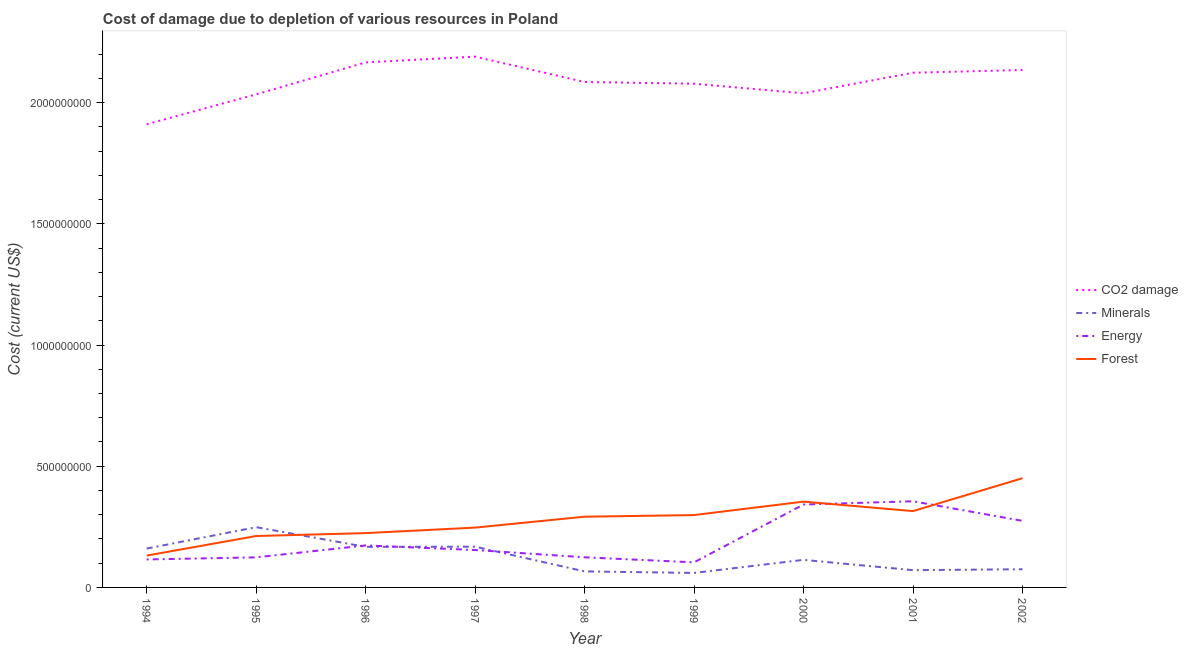What is the cost of damage due to depletion of minerals in 2001?
Provide a short and direct response. 7.12e+07. Across all years, what is the maximum cost of damage due to depletion of forests?
Ensure brevity in your answer.  4.50e+08. Across all years, what is the minimum cost of damage due to depletion of energy?
Make the answer very short. 1.03e+08. In which year was the cost of damage due to depletion of forests minimum?
Keep it short and to the point. 1994. What is the total cost of damage due to depletion of coal in the graph?
Offer a terse response. 1.88e+1. What is the difference between the cost of damage due to depletion of coal in 1998 and that in 2000?
Provide a succinct answer. 4.68e+07. What is the difference between the cost of damage due to depletion of minerals in 1997 and the cost of damage due to depletion of forests in 1995?
Offer a terse response. -4.40e+07. What is the average cost of damage due to depletion of energy per year?
Make the answer very short. 1.96e+08. In the year 1997, what is the difference between the cost of damage due to depletion of minerals and cost of damage due to depletion of energy?
Give a very brief answer. 1.37e+07. What is the ratio of the cost of damage due to depletion of energy in 1997 to that in 2000?
Your answer should be compact. 0.45. Is the cost of damage due to depletion of energy in 1997 less than that in 2001?
Your response must be concise. Yes. Is the difference between the cost of damage due to depletion of forests in 1995 and 1996 greater than the difference between the cost of damage due to depletion of coal in 1995 and 1996?
Offer a terse response. Yes. What is the difference between the highest and the second highest cost of damage due to depletion of energy?
Offer a terse response. 1.34e+07. What is the difference between the highest and the lowest cost of damage due to depletion of coal?
Offer a very short reply. 2.79e+08. In how many years, is the cost of damage due to depletion of minerals greater than the average cost of damage due to depletion of minerals taken over all years?
Your response must be concise. 4. Is it the case that in every year, the sum of the cost of damage due to depletion of minerals and cost of damage due to depletion of forests is greater than the sum of cost of damage due to depletion of energy and cost of damage due to depletion of coal?
Offer a very short reply. No. Is it the case that in every year, the sum of the cost of damage due to depletion of coal and cost of damage due to depletion of minerals is greater than the cost of damage due to depletion of energy?
Offer a terse response. Yes. Does the cost of damage due to depletion of forests monotonically increase over the years?
Offer a very short reply. No. Is the cost of damage due to depletion of forests strictly greater than the cost of damage due to depletion of minerals over the years?
Provide a succinct answer. No. Is the cost of damage due to depletion of coal strictly less than the cost of damage due to depletion of energy over the years?
Offer a very short reply. No. How many years are there in the graph?
Ensure brevity in your answer.  9. Are the values on the major ticks of Y-axis written in scientific E-notation?
Offer a terse response. No. Does the graph contain any zero values?
Provide a short and direct response. No. Does the graph contain grids?
Make the answer very short. No. Where does the legend appear in the graph?
Give a very brief answer. Center right. How many legend labels are there?
Your answer should be compact. 4. What is the title of the graph?
Make the answer very short. Cost of damage due to depletion of various resources in Poland . Does "Compensation of employees" appear as one of the legend labels in the graph?
Ensure brevity in your answer.  No. What is the label or title of the X-axis?
Make the answer very short. Year. What is the label or title of the Y-axis?
Your answer should be compact. Cost (current US$). What is the Cost (current US$) of CO2 damage in 1994?
Make the answer very short. 1.91e+09. What is the Cost (current US$) in Minerals in 1994?
Provide a short and direct response. 1.60e+08. What is the Cost (current US$) of Energy in 1994?
Keep it short and to the point. 1.15e+08. What is the Cost (current US$) in Forest in 1994?
Your answer should be very brief. 1.31e+08. What is the Cost (current US$) in CO2 damage in 1995?
Keep it short and to the point. 2.03e+09. What is the Cost (current US$) in Minerals in 1995?
Offer a terse response. 2.49e+08. What is the Cost (current US$) in Energy in 1995?
Make the answer very short. 1.24e+08. What is the Cost (current US$) of Forest in 1995?
Ensure brevity in your answer.  2.12e+08. What is the Cost (current US$) in CO2 damage in 1996?
Offer a very short reply. 2.17e+09. What is the Cost (current US$) of Minerals in 1996?
Offer a terse response. 1.67e+08. What is the Cost (current US$) of Energy in 1996?
Make the answer very short. 1.73e+08. What is the Cost (current US$) in Forest in 1996?
Provide a succinct answer. 2.24e+08. What is the Cost (current US$) of CO2 damage in 1997?
Make the answer very short. 2.19e+09. What is the Cost (current US$) of Minerals in 1997?
Make the answer very short. 1.68e+08. What is the Cost (current US$) of Energy in 1997?
Provide a succinct answer. 1.54e+08. What is the Cost (current US$) in Forest in 1997?
Your answer should be very brief. 2.47e+08. What is the Cost (current US$) of CO2 damage in 1998?
Provide a short and direct response. 2.09e+09. What is the Cost (current US$) of Minerals in 1998?
Your response must be concise. 6.62e+07. What is the Cost (current US$) in Energy in 1998?
Your response must be concise. 1.24e+08. What is the Cost (current US$) in Forest in 1998?
Your response must be concise. 2.92e+08. What is the Cost (current US$) of CO2 damage in 1999?
Provide a succinct answer. 2.08e+09. What is the Cost (current US$) of Minerals in 1999?
Your answer should be very brief. 5.97e+07. What is the Cost (current US$) of Energy in 1999?
Your answer should be very brief. 1.03e+08. What is the Cost (current US$) of Forest in 1999?
Make the answer very short. 2.98e+08. What is the Cost (current US$) in CO2 damage in 2000?
Ensure brevity in your answer.  2.04e+09. What is the Cost (current US$) of Minerals in 2000?
Ensure brevity in your answer.  1.14e+08. What is the Cost (current US$) of Energy in 2000?
Offer a very short reply. 3.42e+08. What is the Cost (current US$) in Forest in 2000?
Make the answer very short. 3.54e+08. What is the Cost (current US$) in CO2 damage in 2001?
Ensure brevity in your answer.  2.12e+09. What is the Cost (current US$) of Minerals in 2001?
Provide a succinct answer. 7.12e+07. What is the Cost (current US$) in Energy in 2001?
Your answer should be very brief. 3.55e+08. What is the Cost (current US$) in Forest in 2001?
Offer a very short reply. 3.15e+08. What is the Cost (current US$) in CO2 damage in 2002?
Keep it short and to the point. 2.13e+09. What is the Cost (current US$) in Minerals in 2002?
Your response must be concise. 7.50e+07. What is the Cost (current US$) of Energy in 2002?
Provide a short and direct response. 2.75e+08. What is the Cost (current US$) of Forest in 2002?
Your answer should be compact. 4.50e+08. Across all years, what is the maximum Cost (current US$) of CO2 damage?
Your response must be concise. 2.19e+09. Across all years, what is the maximum Cost (current US$) of Minerals?
Offer a terse response. 2.49e+08. Across all years, what is the maximum Cost (current US$) of Energy?
Offer a terse response. 3.55e+08. Across all years, what is the maximum Cost (current US$) of Forest?
Provide a short and direct response. 4.50e+08. Across all years, what is the minimum Cost (current US$) in CO2 damage?
Make the answer very short. 1.91e+09. Across all years, what is the minimum Cost (current US$) of Minerals?
Offer a terse response. 5.97e+07. Across all years, what is the minimum Cost (current US$) in Energy?
Your answer should be compact. 1.03e+08. Across all years, what is the minimum Cost (current US$) in Forest?
Give a very brief answer. 1.31e+08. What is the total Cost (current US$) in CO2 damage in the graph?
Keep it short and to the point. 1.88e+1. What is the total Cost (current US$) in Minerals in the graph?
Offer a very short reply. 1.13e+09. What is the total Cost (current US$) in Energy in the graph?
Your answer should be very brief. 1.77e+09. What is the total Cost (current US$) in Forest in the graph?
Make the answer very short. 2.52e+09. What is the difference between the Cost (current US$) in CO2 damage in 1994 and that in 1995?
Give a very brief answer. -1.23e+08. What is the difference between the Cost (current US$) in Minerals in 1994 and that in 1995?
Keep it short and to the point. -8.83e+07. What is the difference between the Cost (current US$) of Energy in 1994 and that in 1995?
Provide a short and direct response. -8.64e+06. What is the difference between the Cost (current US$) in Forest in 1994 and that in 1995?
Offer a terse response. -8.07e+07. What is the difference between the Cost (current US$) in CO2 damage in 1994 and that in 1996?
Your response must be concise. -2.55e+08. What is the difference between the Cost (current US$) in Minerals in 1994 and that in 1996?
Keep it short and to the point. -7.06e+06. What is the difference between the Cost (current US$) of Energy in 1994 and that in 1996?
Make the answer very short. -5.78e+07. What is the difference between the Cost (current US$) in Forest in 1994 and that in 1996?
Ensure brevity in your answer.  -9.27e+07. What is the difference between the Cost (current US$) in CO2 damage in 1994 and that in 1997?
Your answer should be compact. -2.79e+08. What is the difference between the Cost (current US$) in Minerals in 1994 and that in 1997?
Your answer should be very brief. -7.76e+06. What is the difference between the Cost (current US$) in Energy in 1994 and that in 1997?
Your answer should be compact. -3.90e+07. What is the difference between the Cost (current US$) of Forest in 1994 and that in 1997?
Ensure brevity in your answer.  -1.15e+08. What is the difference between the Cost (current US$) of CO2 damage in 1994 and that in 1998?
Ensure brevity in your answer.  -1.74e+08. What is the difference between the Cost (current US$) of Minerals in 1994 and that in 1998?
Keep it short and to the point. 9.41e+07. What is the difference between the Cost (current US$) of Energy in 1994 and that in 1998?
Your answer should be compact. -8.82e+06. What is the difference between the Cost (current US$) of Forest in 1994 and that in 1998?
Your response must be concise. -1.60e+08. What is the difference between the Cost (current US$) of CO2 damage in 1994 and that in 1999?
Give a very brief answer. -1.67e+08. What is the difference between the Cost (current US$) of Minerals in 1994 and that in 1999?
Ensure brevity in your answer.  1.01e+08. What is the difference between the Cost (current US$) of Energy in 1994 and that in 1999?
Your answer should be very brief. 1.19e+07. What is the difference between the Cost (current US$) in Forest in 1994 and that in 1999?
Provide a succinct answer. -1.67e+08. What is the difference between the Cost (current US$) in CO2 damage in 1994 and that in 2000?
Provide a short and direct response. -1.28e+08. What is the difference between the Cost (current US$) in Minerals in 1994 and that in 2000?
Make the answer very short. 4.66e+07. What is the difference between the Cost (current US$) in Energy in 1994 and that in 2000?
Ensure brevity in your answer.  -2.27e+08. What is the difference between the Cost (current US$) of Forest in 1994 and that in 2000?
Offer a very short reply. -2.23e+08. What is the difference between the Cost (current US$) in CO2 damage in 1994 and that in 2001?
Keep it short and to the point. -2.13e+08. What is the difference between the Cost (current US$) of Minerals in 1994 and that in 2001?
Offer a very short reply. 8.91e+07. What is the difference between the Cost (current US$) of Energy in 1994 and that in 2001?
Offer a very short reply. -2.40e+08. What is the difference between the Cost (current US$) in Forest in 1994 and that in 2001?
Your answer should be compact. -1.84e+08. What is the difference between the Cost (current US$) of CO2 damage in 1994 and that in 2002?
Your answer should be compact. -2.24e+08. What is the difference between the Cost (current US$) of Minerals in 1994 and that in 2002?
Provide a succinct answer. 8.53e+07. What is the difference between the Cost (current US$) of Energy in 1994 and that in 2002?
Your answer should be compact. -1.59e+08. What is the difference between the Cost (current US$) of Forest in 1994 and that in 2002?
Offer a terse response. -3.19e+08. What is the difference between the Cost (current US$) in CO2 damage in 1995 and that in 1996?
Your answer should be compact. -1.32e+08. What is the difference between the Cost (current US$) of Minerals in 1995 and that in 1996?
Provide a short and direct response. 8.12e+07. What is the difference between the Cost (current US$) of Energy in 1995 and that in 1996?
Give a very brief answer. -4.92e+07. What is the difference between the Cost (current US$) of Forest in 1995 and that in 1996?
Provide a succinct answer. -1.20e+07. What is the difference between the Cost (current US$) in CO2 damage in 1995 and that in 1997?
Give a very brief answer. -1.56e+08. What is the difference between the Cost (current US$) in Minerals in 1995 and that in 1997?
Provide a short and direct response. 8.05e+07. What is the difference between the Cost (current US$) of Energy in 1995 and that in 1997?
Provide a succinct answer. -3.04e+07. What is the difference between the Cost (current US$) of Forest in 1995 and that in 1997?
Provide a short and direct response. -3.47e+07. What is the difference between the Cost (current US$) in CO2 damage in 1995 and that in 1998?
Offer a terse response. -5.11e+07. What is the difference between the Cost (current US$) in Minerals in 1995 and that in 1998?
Provide a succinct answer. 1.82e+08. What is the difference between the Cost (current US$) in Energy in 1995 and that in 1998?
Ensure brevity in your answer.  -1.83e+05. What is the difference between the Cost (current US$) of Forest in 1995 and that in 1998?
Ensure brevity in your answer.  -7.97e+07. What is the difference between the Cost (current US$) of CO2 damage in 1995 and that in 1999?
Ensure brevity in your answer.  -4.40e+07. What is the difference between the Cost (current US$) in Minerals in 1995 and that in 1999?
Give a very brief answer. 1.89e+08. What is the difference between the Cost (current US$) in Energy in 1995 and that in 1999?
Your answer should be very brief. 2.06e+07. What is the difference between the Cost (current US$) of Forest in 1995 and that in 1999?
Your answer should be compact. -8.64e+07. What is the difference between the Cost (current US$) in CO2 damage in 1995 and that in 2000?
Offer a very short reply. -4.34e+06. What is the difference between the Cost (current US$) in Minerals in 1995 and that in 2000?
Offer a very short reply. 1.35e+08. What is the difference between the Cost (current US$) in Energy in 1995 and that in 2000?
Offer a terse response. -2.18e+08. What is the difference between the Cost (current US$) in Forest in 1995 and that in 2000?
Make the answer very short. -1.42e+08. What is the difference between the Cost (current US$) of CO2 damage in 1995 and that in 2001?
Your response must be concise. -8.93e+07. What is the difference between the Cost (current US$) in Minerals in 1995 and that in 2001?
Make the answer very short. 1.77e+08. What is the difference between the Cost (current US$) of Energy in 1995 and that in 2001?
Your answer should be very brief. -2.31e+08. What is the difference between the Cost (current US$) in Forest in 1995 and that in 2001?
Your answer should be very brief. -1.03e+08. What is the difference between the Cost (current US$) in CO2 damage in 1995 and that in 2002?
Keep it short and to the point. -1.01e+08. What is the difference between the Cost (current US$) in Minerals in 1995 and that in 2002?
Give a very brief answer. 1.74e+08. What is the difference between the Cost (current US$) in Energy in 1995 and that in 2002?
Ensure brevity in your answer.  -1.51e+08. What is the difference between the Cost (current US$) in Forest in 1995 and that in 2002?
Provide a short and direct response. -2.38e+08. What is the difference between the Cost (current US$) of CO2 damage in 1996 and that in 1997?
Offer a terse response. -2.39e+07. What is the difference between the Cost (current US$) of Minerals in 1996 and that in 1997?
Keep it short and to the point. -6.99e+05. What is the difference between the Cost (current US$) in Energy in 1996 and that in 1997?
Ensure brevity in your answer.  1.88e+07. What is the difference between the Cost (current US$) of Forest in 1996 and that in 1997?
Make the answer very short. -2.27e+07. What is the difference between the Cost (current US$) of CO2 damage in 1996 and that in 1998?
Offer a very short reply. 8.07e+07. What is the difference between the Cost (current US$) of Minerals in 1996 and that in 1998?
Your answer should be very brief. 1.01e+08. What is the difference between the Cost (current US$) in Energy in 1996 and that in 1998?
Make the answer very short. 4.90e+07. What is the difference between the Cost (current US$) of Forest in 1996 and that in 1998?
Offer a terse response. -6.77e+07. What is the difference between the Cost (current US$) of CO2 damage in 1996 and that in 1999?
Make the answer very short. 8.78e+07. What is the difference between the Cost (current US$) of Minerals in 1996 and that in 1999?
Offer a terse response. 1.08e+08. What is the difference between the Cost (current US$) of Energy in 1996 and that in 1999?
Provide a succinct answer. 6.97e+07. What is the difference between the Cost (current US$) in Forest in 1996 and that in 1999?
Provide a short and direct response. -7.44e+07. What is the difference between the Cost (current US$) in CO2 damage in 1996 and that in 2000?
Give a very brief answer. 1.27e+08. What is the difference between the Cost (current US$) of Minerals in 1996 and that in 2000?
Make the answer very short. 5.36e+07. What is the difference between the Cost (current US$) in Energy in 1996 and that in 2000?
Ensure brevity in your answer.  -1.69e+08. What is the difference between the Cost (current US$) of Forest in 1996 and that in 2000?
Give a very brief answer. -1.30e+08. What is the difference between the Cost (current US$) in CO2 damage in 1996 and that in 2001?
Provide a succinct answer. 4.25e+07. What is the difference between the Cost (current US$) of Minerals in 1996 and that in 2001?
Give a very brief answer. 9.62e+07. What is the difference between the Cost (current US$) in Energy in 1996 and that in 2001?
Ensure brevity in your answer.  -1.82e+08. What is the difference between the Cost (current US$) in Forest in 1996 and that in 2001?
Make the answer very short. -9.08e+07. What is the difference between the Cost (current US$) of CO2 damage in 1996 and that in 2002?
Keep it short and to the point. 3.12e+07. What is the difference between the Cost (current US$) in Minerals in 1996 and that in 2002?
Your response must be concise. 9.24e+07. What is the difference between the Cost (current US$) of Energy in 1996 and that in 2002?
Make the answer very short. -1.01e+08. What is the difference between the Cost (current US$) of Forest in 1996 and that in 2002?
Your answer should be very brief. -2.26e+08. What is the difference between the Cost (current US$) in CO2 damage in 1997 and that in 1998?
Keep it short and to the point. 1.05e+08. What is the difference between the Cost (current US$) of Minerals in 1997 and that in 1998?
Offer a very short reply. 1.02e+08. What is the difference between the Cost (current US$) in Energy in 1997 and that in 1998?
Your response must be concise. 3.02e+07. What is the difference between the Cost (current US$) of Forest in 1997 and that in 1998?
Make the answer very short. -4.50e+07. What is the difference between the Cost (current US$) in CO2 damage in 1997 and that in 1999?
Keep it short and to the point. 1.12e+08. What is the difference between the Cost (current US$) of Minerals in 1997 and that in 1999?
Your response must be concise. 1.08e+08. What is the difference between the Cost (current US$) of Energy in 1997 and that in 1999?
Give a very brief answer. 5.09e+07. What is the difference between the Cost (current US$) of Forest in 1997 and that in 1999?
Provide a succinct answer. -5.17e+07. What is the difference between the Cost (current US$) in CO2 damage in 1997 and that in 2000?
Ensure brevity in your answer.  1.51e+08. What is the difference between the Cost (current US$) in Minerals in 1997 and that in 2000?
Keep it short and to the point. 5.43e+07. What is the difference between the Cost (current US$) of Energy in 1997 and that in 2000?
Provide a short and direct response. -1.88e+08. What is the difference between the Cost (current US$) in Forest in 1997 and that in 2000?
Your answer should be compact. -1.07e+08. What is the difference between the Cost (current US$) in CO2 damage in 1997 and that in 2001?
Your answer should be very brief. 6.63e+07. What is the difference between the Cost (current US$) in Minerals in 1997 and that in 2001?
Provide a succinct answer. 9.69e+07. What is the difference between the Cost (current US$) in Energy in 1997 and that in 2001?
Keep it short and to the point. -2.01e+08. What is the difference between the Cost (current US$) of Forest in 1997 and that in 2001?
Give a very brief answer. -6.81e+07. What is the difference between the Cost (current US$) in CO2 damage in 1997 and that in 2002?
Provide a short and direct response. 5.51e+07. What is the difference between the Cost (current US$) in Minerals in 1997 and that in 2002?
Make the answer very short. 9.31e+07. What is the difference between the Cost (current US$) in Energy in 1997 and that in 2002?
Your answer should be very brief. -1.20e+08. What is the difference between the Cost (current US$) of Forest in 1997 and that in 2002?
Your response must be concise. -2.04e+08. What is the difference between the Cost (current US$) in CO2 damage in 1998 and that in 1999?
Give a very brief answer. 7.10e+06. What is the difference between the Cost (current US$) in Minerals in 1998 and that in 1999?
Your response must be concise. 6.44e+06. What is the difference between the Cost (current US$) of Energy in 1998 and that in 1999?
Offer a very short reply. 2.08e+07. What is the difference between the Cost (current US$) in Forest in 1998 and that in 1999?
Keep it short and to the point. -6.70e+06. What is the difference between the Cost (current US$) of CO2 damage in 1998 and that in 2000?
Ensure brevity in your answer.  4.68e+07. What is the difference between the Cost (current US$) in Minerals in 1998 and that in 2000?
Your response must be concise. -4.76e+07. What is the difference between the Cost (current US$) of Energy in 1998 and that in 2000?
Provide a succinct answer. -2.18e+08. What is the difference between the Cost (current US$) in Forest in 1998 and that in 2000?
Your answer should be very brief. -6.22e+07. What is the difference between the Cost (current US$) in CO2 damage in 1998 and that in 2001?
Your answer should be very brief. -3.82e+07. What is the difference between the Cost (current US$) of Minerals in 1998 and that in 2001?
Give a very brief answer. -5.05e+06. What is the difference between the Cost (current US$) in Energy in 1998 and that in 2001?
Your answer should be compact. -2.31e+08. What is the difference between the Cost (current US$) in Forest in 1998 and that in 2001?
Your answer should be compact. -2.32e+07. What is the difference between the Cost (current US$) in CO2 damage in 1998 and that in 2002?
Offer a terse response. -4.95e+07. What is the difference between the Cost (current US$) in Minerals in 1998 and that in 2002?
Make the answer very short. -8.80e+06. What is the difference between the Cost (current US$) in Energy in 1998 and that in 2002?
Your answer should be compact. -1.50e+08. What is the difference between the Cost (current US$) of Forest in 1998 and that in 2002?
Your answer should be very brief. -1.59e+08. What is the difference between the Cost (current US$) in CO2 damage in 1999 and that in 2000?
Provide a short and direct response. 3.97e+07. What is the difference between the Cost (current US$) of Minerals in 1999 and that in 2000?
Provide a short and direct response. -5.40e+07. What is the difference between the Cost (current US$) of Energy in 1999 and that in 2000?
Provide a succinct answer. -2.39e+08. What is the difference between the Cost (current US$) in Forest in 1999 and that in 2000?
Offer a very short reply. -5.55e+07. What is the difference between the Cost (current US$) of CO2 damage in 1999 and that in 2001?
Provide a succinct answer. -4.53e+07. What is the difference between the Cost (current US$) in Minerals in 1999 and that in 2001?
Ensure brevity in your answer.  -1.15e+07. What is the difference between the Cost (current US$) in Energy in 1999 and that in 2001?
Your answer should be very brief. -2.52e+08. What is the difference between the Cost (current US$) in Forest in 1999 and that in 2001?
Make the answer very short. -1.65e+07. What is the difference between the Cost (current US$) of CO2 damage in 1999 and that in 2002?
Provide a succinct answer. -5.66e+07. What is the difference between the Cost (current US$) in Minerals in 1999 and that in 2002?
Your answer should be very brief. -1.52e+07. What is the difference between the Cost (current US$) of Energy in 1999 and that in 2002?
Give a very brief answer. -1.71e+08. What is the difference between the Cost (current US$) of Forest in 1999 and that in 2002?
Your answer should be very brief. -1.52e+08. What is the difference between the Cost (current US$) of CO2 damage in 2000 and that in 2001?
Give a very brief answer. -8.50e+07. What is the difference between the Cost (current US$) in Minerals in 2000 and that in 2001?
Your answer should be very brief. 4.25e+07. What is the difference between the Cost (current US$) of Energy in 2000 and that in 2001?
Your answer should be compact. -1.34e+07. What is the difference between the Cost (current US$) in Forest in 2000 and that in 2001?
Ensure brevity in your answer.  3.90e+07. What is the difference between the Cost (current US$) of CO2 damage in 2000 and that in 2002?
Provide a short and direct response. -9.62e+07. What is the difference between the Cost (current US$) in Minerals in 2000 and that in 2002?
Your answer should be very brief. 3.88e+07. What is the difference between the Cost (current US$) in Energy in 2000 and that in 2002?
Your response must be concise. 6.73e+07. What is the difference between the Cost (current US$) in Forest in 2000 and that in 2002?
Provide a short and direct response. -9.65e+07. What is the difference between the Cost (current US$) in CO2 damage in 2001 and that in 2002?
Provide a short and direct response. -1.12e+07. What is the difference between the Cost (current US$) in Minerals in 2001 and that in 2002?
Provide a succinct answer. -3.75e+06. What is the difference between the Cost (current US$) in Energy in 2001 and that in 2002?
Your answer should be very brief. 8.07e+07. What is the difference between the Cost (current US$) in Forest in 2001 and that in 2002?
Ensure brevity in your answer.  -1.36e+08. What is the difference between the Cost (current US$) in CO2 damage in 1994 and the Cost (current US$) in Minerals in 1995?
Provide a succinct answer. 1.66e+09. What is the difference between the Cost (current US$) of CO2 damage in 1994 and the Cost (current US$) of Energy in 1995?
Ensure brevity in your answer.  1.79e+09. What is the difference between the Cost (current US$) in CO2 damage in 1994 and the Cost (current US$) in Forest in 1995?
Your answer should be very brief. 1.70e+09. What is the difference between the Cost (current US$) in Minerals in 1994 and the Cost (current US$) in Energy in 1995?
Give a very brief answer. 3.63e+07. What is the difference between the Cost (current US$) of Minerals in 1994 and the Cost (current US$) of Forest in 1995?
Your answer should be compact. -5.18e+07. What is the difference between the Cost (current US$) in Energy in 1994 and the Cost (current US$) in Forest in 1995?
Your answer should be very brief. -9.67e+07. What is the difference between the Cost (current US$) of CO2 damage in 1994 and the Cost (current US$) of Minerals in 1996?
Your answer should be very brief. 1.74e+09. What is the difference between the Cost (current US$) of CO2 damage in 1994 and the Cost (current US$) of Energy in 1996?
Offer a very short reply. 1.74e+09. What is the difference between the Cost (current US$) in CO2 damage in 1994 and the Cost (current US$) in Forest in 1996?
Offer a terse response. 1.69e+09. What is the difference between the Cost (current US$) of Minerals in 1994 and the Cost (current US$) of Energy in 1996?
Offer a terse response. -1.29e+07. What is the difference between the Cost (current US$) in Minerals in 1994 and the Cost (current US$) in Forest in 1996?
Make the answer very short. -6.38e+07. What is the difference between the Cost (current US$) in Energy in 1994 and the Cost (current US$) in Forest in 1996?
Keep it short and to the point. -1.09e+08. What is the difference between the Cost (current US$) in CO2 damage in 1994 and the Cost (current US$) in Minerals in 1997?
Give a very brief answer. 1.74e+09. What is the difference between the Cost (current US$) in CO2 damage in 1994 and the Cost (current US$) in Energy in 1997?
Offer a terse response. 1.76e+09. What is the difference between the Cost (current US$) of CO2 damage in 1994 and the Cost (current US$) of Forest in 1997?
Provide a succinct answer. 1.66e+09. What is the difference between the Cost (current US$) of Minerals in 1994 and the Cost (current US$) of Energy in 1997?
Offer a very short reply. 5.92e+06. What is the difference between the Cost (current US$) in Minerals in 1994 and the Cost (current US$) in Forest in 1997?
Your answer should be compact. -8.65e+07. What is the difference between the Cost (current US$) of Energy in 1994 and the Cost (current US$) of Forest in 1997?
Your response must be concise. -1.31e+08. What is the difference between the Cost (current US$) in CO2 damage in 1994 and the Cost (current US$) in Minerals in 1998?
Offer a very short reply. 1.84e+09. What is the difference between the Cost (current US$) of CO2 damage in 1994 and the Cost (current US$) of Energy in 1998?
Your response must be concise. 1.79e+09. What is the difference between the Cost (current US$) of CO2 damage in 1994 and the Cost (current US$) of Forest in 1998?
Your answer should be very brief. 1.62e+09. What is the difference between the Cost (current US$) in Minerals in 1994 and the Cost (current US$) in Energy in 1998?
Your response must be concise. 3.61e+07. What is the difference between the Cost (current US$) in Minerals in 1994 and the Cost (current US$) in Forest in 1998?
Provide a succinct answer. -1.31e+08. What is the difference between the Cost (current US$) in Energy in 1994 and the Cost (current US$) in Forest in 1998?
Ensure brevity in your answer.  -1.76e+08. What is the difference between the Cost (current US$) in CO2 damage in 1994 and the Cost (current US$) in Minerals in 1999?
Offer a very short reply. 1.85e+09. What is the difference between the Cost (current US$) of CO2 damage in 1994 and the Cost (current US$) of Energy in 1999?
Your answer should be very brief. 1.81e+09. What is the difference between the Cost (current US$) in CO2 damage in 1994 and the Cost (current US$) in Forest in 1999?
Make the answer very short. 1.61e+09. What is the difference between the Cost (current US$) in Minerals in 1994 and the Cost (current US$) in Energy in 1999?
Make the answer very short. 5.68e+07. What is the difference between the Cost (current US$) of Minerals in 1994 and the Cost (current US$) of Forest in 1999?
Ensure brevity in your answer.  -1.38e+08. What is the difference between the Cost (current US$) of Energy in 1994 and the Cost (current US$) of Forest in 1999?
Offer a very short reply. -1.83e+08. What is the difference between the Cost (current US$) of CO2 damage in 1994 and the Cost (current US$) of Minerals in 2000?
Keep it short and to the point. 1.80e+09. What is the difference between the Cost (current US$) of CO2 damage in 1994 and the Cost (current US$) of Energy in 2000?
Offer a very short reply. 1.57e+09. What is the difference between the Cost (current US$) of CO2 damage in 1994 and the Cost (current US$) of Forest in 2000?
Your response must be concise. 1.56e+09. What is the difference between the Cost (current US$) in Minerals in 1994 and the Cost (current US$) in Energy in 2000?
Offer a terse response. -1.82e+08. What is the difference between the Cost (current US$) in Minerals in 1994 and the Cost (current US$) in Forest in 2000?
Your answer should be compact. -1.94e+08. What is the difference between the Cost (current US$) of Energy in 1994 and the Cost (current US$) of Forest in 2000?
Your response must be concise. -2.39e+08. What is the difference between the Cost (current US$) of CO2 damage in 1994 and the Cost (current US$) of Minerals in 2001?
Ensure brevity in your answer.  1.84e+09. What is the difference between the Cost (current US$) of CO2 damage in 1994 and the Cost (current US$) of Energy in 2001?
Keep it short and to the point. 1.56e+09. What is the difference between the Cost (current US$) of CO2 damage in 1994 and the Cost (current US$) of Forest in 2001?
Your answer should be very brief. 1.60e+09. What is the difference between the Cost (current US$) of Minerals in 1994 and the Cost (current US$) of Energy in 2001?
Offer a terse response. -1.95e+08. What is the difference between the Cost (current US$) of Minerals in 1994 and the Cost (current US$) of Forest in 2001?
Offer a terse response. -1.55e+08. What is the difference between the Cost (current US$) in Energy in 1994 and the Cost (current US$) in Forest in 2001?
Keep it short and to the point. -2.00e+08. What is the difference between the Cost (current US$) of CO2 damage in 1994 and the Cost (current US$) of Minerals in 2002?
Your response must be concise. 1.84e+09. What is the difference between the Cost (current US$) of CO2 damage in 1994 and the Cost (current US$) of Energy in 2002?
Make the answer very short. 1.64e+09. What is the difference between the Cost (current US$) in CO2 damage in 1994 and the Cost (current US$) in Forest in 2002?
Offer a very short reply. 1.46e+09. What is the difference between the Cost (current US$) of Minerals in 1994 and the Cost (current US$) of Energy in 2002?
Make the answer very short. -1.14e+08. What is the difference between the Cost (current US$) in Minerals in 1994 and the Cost (current US$) in Forest in 2002?
Your answer should be very brief. -2.90e+08. What is the difference between the Cost (current US$) in Energy in 1994 and the Cost (current US$) in Forest in 2002?
Offer a very short reply. -3.35e+08. What is the difference between the Cost (current US$) in CO2 damage in 1995 and the Cost (current US$) in Minerals in 1996?
Make the answer very short. 1.87e+09. What is the difference between the Cost (current US$) of CO2 damage in 1995 and the Cost (current US$) of Energy in 1996?
Give a very brief answer. 1.86e+09. What is the difference between the Cost (current US$) of CO2 damage in 1995 and the Cost (current US$) of Forest in 1996?
Make the answer very short. 1.81e+09. What is the difference between the Cost (current US$) of Minerals in 1995 and the Cost (current US$) of Energy in 1996?
Keep it short and to the point. 7.54e+07. What is the difference between the Cost (current US$) of Minerals in 1995 and the Cost (current US$) of Forest in 1996?
Provide a short and direct response. 2.45e+07. What is the difference between the Cost (current US$) of Energy in 1995 and the Cost (current US$) of Forest in 1996?
Offer a very short reply. -1.00e+08. What is the difference between the Cost (current US$) of CO2 damage in 1995 and the Cost (current US$) of Minerals in 1997?
Offer a very short reply. 1.87e+09. What is the difference between the Cost (current US$) in CO2 damage in 1995 and the Cost (current US$) in Energy in 1997?
Offer a very short reply. 1.88e+09. What is the difference between the Cost (current US$) in CO2 damage in 1995 and the Cost (current US$) in Forest in 1997?
Provide a short and direct response. 1.79e+09. What is the difference between the Cost (current US$) of Minerals in 1995 and the Cost (current US$) of Energy in 1997?
Provide a short and direct response. 9.42e+07. What is the difference between the Cost (current US$) in Minerals in 1995 and the Cost (current US$) in Forest in 1997?
Give a very brief answer. 1.80e+06. What is the difference between the Cost (current US$) of Energy in 1995 and the Cost (current US$) of Forest in 1997?
Offer a terse response. -1.23e+08. What is the difference between the Cost (current US$) of CO2 damage in 1995 and the Cost (current US$) of Minerals in 1998?
Keep it short and to the point. 1.97e+09. What is the difference between the Cost (current US$) of CO2 damage in 1995 and the Cost (current US$) of Energy in 1998?
Ensure brevity in your answer.  1.91e+09. What is the difference between the Cost (current US$) of CO2 damage in 1995 and the Cost (current US$) of Forest in 1998?
Your answer should be very brief. 1.74e+09. What is the difference between the Cost (current US$) of Minerals in 1995 and the Cost (current US$) of Energy in 1998?
Give a very brief answer. 1.24e+08. What is the difference between the Cost (current US$) of Minerals in 1995 and the Cost (current US$) of Forest in 1998?
Your response must be concise. -4.32e+07. What is the difference between the Cost (current US$) in Energy in 1995 and the Cost (current US$) in Forest in 1998?
Keep it short and to the point. -1.68e+08. What is the difference between the Cost (current US$) in CO2 damage in 1995 and the Cost (current US$) in Minerals in 1999?
Offer a terse response. 1.97e+09. What is the difference between the Cost (current US$) of CO2 damage in 1995 and the Cost (current US$) of Energy in 1999?
Ensure brevity in your answer.  1.93e+09. What is the difference between the Cost (current US$) in CO2 damage in 1995 and the Cost (current US$) in Forest in 1999?
Make the answer very short. 1.74e+09. What is the difference between the Cost (current US$) of Minerals in 1995 and the Cost (current US$) of Energy in 1999?
Provide a short and direct response. 1.45e+08. What is the difference between the Cost (current US$) of Minerals in 1995 and the Cost (current US$) of Forest in 1999?
Make the answer very short. -4.99e+07. What is the difference between the Cost (current US$) of Energy in 1995 and the Cost (current US$) of Forest in 1999?
Your response must be concise. -1.74e+08. What is the difference between the Cost (current US$) in CO2 damage in 1995 and the Cost (current US$) in Minerals in 2000?
Your answer should be compact. 1.92e+09. What is the difference between the Cost (current US$) of CO2 damage in 1995 and the Cost (current US$) of Energy in 2000?
Provide a short and direct response. 1.69e+09. What is the difference between the Cost (current US$) of CO2 damage in 1995 and the Cost (current US$) of Forest in 2000?
Offer a terse response. 1.68e+09. What is the difference between the Cost (current US$) of Minerals in 1995 and the Cost (current US$) of Energy in 2000?
Your answer should be very brief. -9.34e+07. What is the difference between the Cost (current US$) of Minerals in 1995 and the Cost (current US$) of Forest in 2000?
Provide a succinct answer. -1.05e+08. What is the difference between the Cost (current US$) in Energy in 1995 and the Cost (current US$) in Forest in 2000?
Make the answer very short. -2.30e+08. What is the difference between the Cost (current US$) in CO2 damage in 1995 and the Cost (current US$) in Minerals in 2001?
Provide a short and direct response. 1.96e+09. What is the difference between the Cost (current US$) of CO2 damage in 1995 and the Cost (current US$) of Energy in 2001?
Provide a succinct answer. 1.68e+09. What is the difference between the Cost (current US$) of CO2 damage in 1995 and the Cost (current US$) of Forest in 2001?
Keep it short and to the point. 1.72e+09. What is the difference between the Cost (current US$) of Minerals in 1995 and the Cost (current US$) of Energy in 2001?
Provide a short and direct response. -1.07e+08. What is the difference between the Cost (current US$) in Minerals in 1995 and the Cost (current US$) in Forest in 2001?
Provide a succinct answer. -6.63e+07. What is the difference between the Cost (current US$) of Energy in 1995 and the Cost (current US$) of Forest in 2001?
Offer a very short reply. -1.91e+08. What is the difference between the Cost (current US$) of CO2 damage in 1995 and the Cost (current US$) of Minerals in 2002?
Your response must be concise. 1.96e+09. What is the difference between the Cost (current US$) in CO2 damage in 1995 and the Cost (current US$) in Energy in 2002?
Provide a succinct answer. 1.76e+09. What is the difference between the Cost (current US$) of CO2 damage in 1995 and the Cost (current US$) of Forest in 2002?
Your answer should be very brief. 1.58e+09. What is the difference between the Cost (current US$) of Minerals in 1995 and the Cost (current US$) of Energy in 2002?
Ensure brevity in your answer.  -2.61e+07. What is the difference between the Cost (current US$) in Minerals in 1995 and the Cost (current US$) in Forest in 2002?
Offer a terse response. -2.02e+08. What is the difference between the Cost (current US$) in Energy in 1995 and the Cost (current US$) in Forest in 2002?
Offer a very short reply. -3.26e+08. What is the difference between the Cost (current US$) of CO2 damage in 1996 and the Cost (current US$) of Minerals in 1997?
Provide a short and direct response. 2.00e+09. What is the difference between the Cost (current US$) of CO2 damage in 1996 and the Cost (current US$) of Energy in 1997?
Offer a terse response. 2.01e+09. What is the difference between the Cost (current US$) in CO2 damage in 1996 and the Cost (current US$) in Forest in 1997?
Give a very brief answer. 1.92e+09. What is the difference between the Cost (current US$) in Minerals in 1996 and the Cost (current US$) in Energy in 1997?
Provide a succinct answer. 1.30e+07. What is the difference between the Cost (current US$) in Minerals in 1996 and the Cost (current US$) in Forest in 1997?
Keep it short and to the point. -7.94e+07. What is the difference between the Cost (current US$) of Energy in 1996 and the Cost (current US$) of Forest in 1997?
Offer a terse response. -7.36e+07. What is the difference between the Cost (current US$) of CO2 damage in 1996 and the Cost (current US$) of Minerals in 1998?
Keep it short and to the point. 2.10e+09. What is the difference between the Cost (current US$) in CO2 damage in 1996 and the Cost (current US$) in Energy in 1998?
Keep it short and to the point. 2.04e+09. What is the difference between the Cost (current US$) in CO2 damage in 1996 and the Cost (current US$) in Forest in 1998?
Ensure brevity in your answer.  1.87e+09. What is the difference between the Cost (current US$) in Minerals in 1996 and the Cost (current US$) in Energy in 1998?
Your response must be concise. 4.32e+07. What is the difference between the Cost (current US$) of Minerals in 1996 and the Cost (current US$) of Forest in 1998?
Provide a short and direct response. -1.24e+08. What is the difference between the Cost (current US$) of Energy in 1996 and the Cost (current US$) of Forest in 1998?
Give a very brief answer. -1.19e+08. What is the difference between the Cost (current US$) of CO2 damage in 1996 and the Cost (current US$) of Minerals in 1999?
Provide a short and direct response. 2.11e+09. What is the difference between the Cost (current US$) in CO2 damage in 1996 and the Cost (current US$) in Energy in 1999?
Offer a very short reply. 2.06e+09. What is the difference between the Cost (current US$) of CO2 damage in 1996 and the Cost (current US$) of Forest in 1999?
Your answer should be compact. 1.87e+09. What is the difference between the Cost (current US$) of Minerals in 1996 and the Cost (current US$) of Energy in 1999?
Make the answer very short. 6.39e+07. What is the difference between the Cost (current US$) of Minerals in 1996 and the Cost (current US$) of Forest in 1999?
Ensure brevity in your answer.  -1.31e+08. What is the difference between the Cost (current US$) in Energy in 1996 and the Cost (current US$) in Forest in 1999?
Your answer should be compact. -1.25e+08. What is the difference between the Cost (current US$) of CO2 damage in 1996 and the Cost (current US$) of Minerals in 2000?
Your answer should be compact. 2.05e+09. What is the difference between the Cost (current US$) in CO2 damage in 1996 and the Cost (current US$) in Energy in 2000?
Your answer should be compact. 1.82e+09. What is the difference between the Cost (current US$) in CO2 damage in 1996 and the Cost (current US$) in Forest in 2000?
Ensure brevity in your answer.  1.81e+09. What is the difference between the Cost (current US$) in Minerals in 1996 and the Cost (current US$) in Energy in 2000?
Your answer should be very brief. -1.75e+08. What is the difference between the Cost (current US$) of Minerals in 1996 and the Cost (current US$) of Forest in 2000?
Keep it short and to the point. -1.87e+08. What is the difference between the Cost (current US$) in Energy in 1996 and the Cost (current US$) in Forest in 2000?
Keep it short and to the point. -1.81e+08. What is the difference between the Cost (current US$) in CO2 damage in 1996 and the Cost (current US$) in Minerals in 2001?
Offer a terse response. 2.09e+09. What is the difference between the Cost (current US$) in CO2 damage in 1996 and the Cost (current US$) in Energy in 2001?
Make the answer very short. 1.81e+09. What is the difference between the Cost (current US$) of CO2 damage in 1996 and the Cost (current US$) of Forest in 2001?
Offer a very short reply. 1.85e+09. What is the difference between the Cost (current US$) of Minerals in 1996 and the Cost (current US$) of Energy in 2001?
Provide a succinct answer. -1.88e+08. What is the difference between the Cost (current US$) in Minerals in 1996 and the Cost (current US$) in Forest in 2001?
Keep it short and to the point. -1.48e+08. What is the difference between the Cost (current US$) in Energy in 1996 and the Cost (current US$) in Forest in 2001?
Ensure brevity in your answer.  -1.42e+08. What is the difference between the Cost (current US$) in CO2 damage in 1996 and the Cost (current US$) in Minerals in 2002?
Make the answer very short. 2.09e+09. What is the difference between the Cost (current US$) in CO2 damage in 1996 and the Cost (current US$) in Energy in 2002?
Provide a succinct answer. 1.89e+09. What is the difference between the Cost (current US$) of CO2 damage in 1996 and the Cost (current US$) of Forest in 2002?
Offer a terse response. 1.72e+09. What is the difference between the Cost (current US$) in Minerals in 1996 and the Cost (current US$) in Energy in 2002?
Offer a terse response. -1.07e+08. What is the difference between the Cost (current US$) of Minerals in 1996 and the Cost (current US$) of Forest in 2002?
Provide a succinct answer. -2.83e+08. What is the difference between the Cost (current US$) in Energy in 1996 and the Cost (current US$) in Forest in 2002?
Your answer should be very brief. -2.77e+08. What is the difference between the Cost (current US$) in CO2 damage in 1997 and the Cost (current US$) in Minerals in 1998?
Offer a terse response. 2.12e+09. What is the difference between the Cost (current US$) in CO2 damage in 1997 and the Cost (current US$) in Energy in 1998?
Your answer should be very brief. 2.07e+09. What is the difference between the Cost (current US$) of CO2 damage in 1997 and the Cost (current US$) of Forest in 1998?
Give a very brief answer. 1.90e+09. What is the difference between the Cost (current US$) of Minerals in 1997 and the Cost (current US$) of Energy in 1998?
Provide a succinct answer. 4.39e+07. What is the difference between the Cost (current US$) in Minerals in 1997 and the Cost (current US$) in Forest in 1998?
Keep it short and to the point. -1.24e+08. What is the difference between the Cost (current US$) of Energy in 1997 and the Cost (current US$) of Forest in 1998?
Provide a short and direct response. -1.37e+08. What is the difference between the Cost (current US$) of CO2 damage in 1997 and the Cost (current US$) of Minerals in 1999?
Your answer should be very brief. 2.13e+09. What is the difference between the Cost (current US$) of CO2 damage in 1997 and the Cost (current US$) of Energy in 1999?
Your response must be concise. 2.09e+09. What is the difference between the Cost (current US$) of CO2 damage in 1997 and the Cost (current US$) of Forest in 1999?
Your answer should be compact. 1.89e+09. What is the difference between the Cost (current US$) in Minerals in 1997 and the Cost (current US$) in Energy in 1999?
Ensure brevity in your answer.  6.46e+07. What is the difference between the Cost (current US$) in Minerals in 1997 and the Cost (current US$) in Forest in 1999?
Offer a very short reply. -1.30e+08. What is the difference between the Cost (current US$) of Energy in 1997 and the Cost (current US$) of Forest in 1999?
Offer a terse response. -1.44e+08. What is the difference between the Cost (current US$) of CO2 damage in 1997 and the Cost (current US$) of Minerals in 2000?
Ensure brevity in your answer.  2.08e+09. What is the difference between the Cost (current US$) in CO2 damage in 1997 and the Cost (current US$) in Energy in 2000?
Provide a short and direct response. 1.85e+09. What is the difference between the Cost (current US$) of CO2 damage in 1997 and the Cost (current US$) of Forest in 2000?
Your answer should be compact. 1.84e+09. What is the difference between the Cost (current US$) in Minerals in 1997 and the Cost (current US$) in Energy in 2000?
Ensure brevity in your answer.  -1.74e+08. What is the difference between the Cost (current US$) in Minerals in 1997 and the Cost (current US$) in Forest in 2000?
Give a very brief answer. -1.86e+08. What is the difference between the Cost (current US$) in Energy in 1997 and the Cost (current US$) in Forest in 2000?
Your response must be concise. -2.00e+08. What is the difference between the Cost (current US$) in CO2 damage in 1997 and the Cost (current US$) in Minerals in 2001?
Offer a terse response. 2.12e+09. What is the difference between the Cost (current US$) of CO2 damage in 1997 and the Cost (current US$) of Energy in 2001?
Give a very brief answer. 1.83e+09. What is the difference between the Cost (current US$) in CO2 damage in 1997 and the Cost (current US$) in Forest in 2001?
Your response must be concise. 1.87e+09. What is the difference between the Cost (current US$) of Minerals in 1997 and the Cost (current US$) of Energy in 2001?
Offer a very short reply. -1.87e+08. What is the difference between the Cost (current US$) of Minerals in 1997 and the Cost (current US$) of Forest in 2001?
Offer a very short reply. -1.47e+08. What is the difference between the Cost (current US$) in Energy in 1997 and the Cost (current US$) in Forest in 2001?
Your response must be concise. -1.61e+08. What is the difference between the Cost (current US$) in CO2 damage in 1997 and the Cost (current US$) in Minerals in 2002?
Ensure brevity in your answer.  2.11e+09. What is the difference between the Cost (current US$) of CO2 damage in 1997 and the Cost (current US$) of Energy in 2002?
Your response must be concise. 1.91e+09. What is the difference between the Cost (current US$) of CO2 damage in 1997 and the Cost (current US$) of Forest in 2002?
Your response must be concise. 1.74e+09. What is the difference between the Cost (current US$) in Minerals in 1997 and the Cost (current US$) in Energy in 2002?
Provide a succinct answer. -1.07e+08. What is the difference between the Cost (current US$) of Minerals in 1997 and the Cost (current US$) of Forest in 2002?
Offer a very short reply. -2.82e+08. What is the difference between the Cost (current US$) of Energy in 1997 and the Cost (current US$) of Forest in 2002?
Provide a succinct answer. -2.96e+08. What is the difference between the Cost (current US$) in CO2 damage in 1998 and the Cost (current US$) in Minerals in 1999?
Your answer should be compact. 2.03e+09. What is the difference between the Cost (current US$) of CO2 damage in 1998 and the Cost (current US$) of Energy in 1999?
Your response must be concise. 1.98e+09. What is the difference between the Cost (current US$) of CO2 damage in 1998 and the Cost (current US$) of Forest in 1999?
Your response must be concise. 1.79e+09. What is the difference between the Cost (current US$) in Minerals in 1998 and the Cost (current US$) in Energy in 1999?
Ensure brevity in your answer.  -3.73e+07. What is the difference between the Cost (current US$) in Minerals in 1998 and the Cost (current US$) in Forest in 1999?
Your response must be concise. -2.32e+08. What is the difference between the Cost (current US$) in Energy in 1998 and the Cost (current US$) in Forest in 1999?
Your answer should be very brief. -1.74e+08. What is the difference between the Cost (current US$) in CO2 damage in 1998 and the Cost (current US$) in Minerals in 2000?
Give a very brief answer. 1.97e+09. What is the difference between the Cost (current US$) of CO2 damage in 1998 and the Cost (current US$) of Energy in 2000?
Your answer should be very brief. 1.74e+09. What is the difference between the Cost (current US$) of CO2 damage in 1998 and the Cost (current US$) of Forest in 2000?
Your answer should be very brief. 1.73e+09. What is the difference between the Cost (current US$) in Minerals in 1998 and the Cost (current US$) in Energy in 2000?
Your answer should be compact. -2.76e+08. What is the difference between the Cost (current US$) of Minerals in 1998 and the Cost (current US$) of Forest in 2000?
Your answer should be compact. -2.88e+08. What is the difference between the Cost (current US$) in Energy in 1998 and the Cost (current US$) in Forest in 2000?
Your response must be concise. -2.30e+08. What is the difference between the Cost (current US$) of CO2 damage in 1998 and the Cost (current US$) of Minerals in 2001?
Give a very brief answer. 2.01e+09. What is the difference between the Cost (current US$) of CO2 damage in 1998 and the Cost (current US$) of Energy in 2001?
Give a very brief answer. 1.73e+09. What is the difference between the Cost (current US$) in CO2 damage in 1998 and the Cost (current US$) in Forest in 2001?
Keep it short and to the point. 1.77e+09. What is the difference between the Cost (current US$) of Minerals in 1998 and the Cost (current US$) of Energy in 2001?
Offer a very short reply. -2.89e+08. What is the difference between the Cost (current US$) in Minerals in 1998 and the Cost (current US$) in Forest in 2001?
Keep it short and to the point. -2.49e+08. What is the difference between the Cost (current US$) in Energy in 1998 and the Cost (current US$) in Forest in 2001?
Keep it short and to the point. -1.91e+08. What is the difference between the Cost (current US$) in CO2 damage in 1998 and the Cost (current US$) in Minerals in 2002?
Make the answer very short. 2.01e+09. What is the difference between the Cost (current US$) in CO2 damage in 1998 and the Cost (current US$) in Energy in 2002?
Provide a succinct answer. 1.81e+09. What is the difference between the Cost (current US$) in CO2 damage in 1998 and the Cost (current US$) in Forest in 2002?
Offer a terse response. 1.63e+09. What is the difference between the Cost (current US$) in Minerals in 1998 and the Cost (current US$) in Energy in 2002?
Your answer should be very brief. -2.08e+08. What is the difference between the Cost (current US$) of Minerals in 1998 and the Cost (current US$) of Forest in 2002?
Your answer should be compact. -3.84e+08. What is the difference between the Cost (current US$) in Energy in 1998 and the Cost (current US$) in Forest in 2002?
Offer a terse response. -3.26e+08. What is the difference between the Cost (current US$) in CO2 damage in 1999 and the Cost (current US$) in Minerals in 2000?
Give a very brief answer. 1.96e+09. What is the difference between the Cost (current US$) in CO2 damage in 1999 and the Cost (current US$) in Energy in 2000?
Ensure brevity in your answer.  1.74e+09. What is the difference between the Cost (current US$) in CO2 damage in 1999 and the Cost (current US$) in Forest in 2000?
Offer a very short reply. 1.72e+09. What is the difference between the Cost (current US$) of Minerals in 1999 and the Cost (current US$) of Energy in 2000?
Your response must be concise. -2.82e+08. What is the difference between the Cost (current US$) in Minerals in 1999 and the Cost (current US$) in Forest in 2000?
Offer a very short reply. -2.94e+08. What is the difference between the Cost (current US$) of Energy in 1999 and the Cost (current US$) of Forest in 2000?
Keep it short and to the point. -2.50e+08. What is the difference between the Cost (current US$) in CO2 damage in 1999 and the Cost (current US$) in Minerals in 2001?
Give a very brief answer. 2.01e+09. What is the difference between the Cost (current US$) in CO2 damage in 1999 and the Cost (current US$) in Energy in 2001?
Keep it short and to the point. 1.72e+09. What is the difference between the Cost (current US$) in CO2 damage in 1999 and the Cost (current US$) in Forest in 2001?
Provide a short and direct response. 1.76e+09. What is the difference between the Cost (current US$) in Minerals in 1999 and the Cost (current US$) in Energy in 2001?
Your answer should be very brief. -2.96e+08. What is the difference between the Cost (current US$) in Minerals in 1999 and the Cost (current US$) in Forest in 2001?
Keep it short and to the point. -2.55e+08. What is the difference between the Cost (current US$) in Energy in 1999 and the Cost (current US$) in Forest in 2001?
Offer a terse response. -2.11e+08. What is the difference between the Cost (current US$) of CO2 damage in 1999 and the Cost (current US$) of Minerals in 2002?
Your answer should be very brief. 2.00e+09. What is the difference between the Cost (current US$) in CO2 damage in 1999 and the Cost (current US$) in Energy in 2002?
Ensure brevity in your answer.  1.80e+09. What is the difference between the Cost (current US$) in CO2 damage in 1999 and the Cost (current US$) in Forest in 2002?
Your answer should be very brief. 1.63e+09. What is the difference between the Cost (current US$) of Minerals in 1999 and the Cost (current US$) of Energy in 2002?
Provide a short and direct response. -2.15e+08. What is the difference between the Cost (current US$) of Minerals in 1999 and the Cost (current US$) of Forest in 2002?
Provide a succinct answer. -3.91e+08. What is the difference between the Cost (current US$) of Energy in 1999 and the Cost (current US$) of Forest in 2002?
Provide a short and direct response. -3.47e+08. What is the difference between the Cost (current US$) of CO2 damage in 2000 and the Cost (current US$) of Minerals in 2001?
Offer a terse response. 1.97e+09. What is the difference between the Cost (current US$) of CO2 damage in 2000 and the Cost (current US$) of Energy in 2001?
Give a very brief answer. 1.68e+09. What is the difference between the Cost (current US$) of CO2 damage in 2000 and the Cost (current US$) of Forest in 2001?
Give a very brief answer. 1.72e+09. What is the difference between the Cost (current US$) of Minerals in 2000 and the Cost (current US$) of Energy in 2001?
Your answer should be very brief. -2.42e+08. What is the difference between the Cost (current US$) in Minerals in 2000 and the Cost (current US$) in Forest in 2001?
Provide a succinct answer. -2.01e+08. What is the difference between the Cost (current US$) of Energy in 2000 and the Cost (current US$) of Forest in 2001?
Provide a short and direct response. 2.71e+07. What is the difference between the Cost (current US$) of CO2 damage in 2000 and the Cost (current US$) of Minerals in 2002?
Provide a succinct answer. 1.96e+09. What is the difference between the Cost (current US$) of CO2 damage in 2000 and the Cost (current US$) of Energy in 2002?
Give a very brief answer. 1.76e+09. What is the difference between the Cost (current US$) in CO2 damage in 2000 and the Cost (current US$) in Forest in 2002?
Your response must be concise. 1.59e+09. What is the difference between the Cost (current US$) in Minerals in 2000 and the Cost (current US$) in Energy in 2002?
Your answer should be very brief. -1.61e+08. What is the difference between the Cost (current US$) of Minerals in 2000 and the Cost (current US$) of Forest in 2002?
Your answer should be very brief. -3.37e+08. What is the difference between the Cost (current US$) of Energy in 2000 and the Cost (current US$) of Forest in 2002?
Your answer should be compact. -1.08e+08. What is the difference between the Cost (current US$) of CO2 damage in 2001 and the Cost (current US$) of Minerals in 2002?
Provide a short and direct response. 2.05e+09. What is the difference between the Cost (current US$) in CO2 damage in 2001 and the Cost (current US$) in Energy in 2002?
Make the answer very short. 1.85e+09. What is the difference between the Cost (current US$) in CO2 damage in 2001 and the Cost (current US$) in Forest in 2002?
Your answer should be compact. 1.67e+09. What is the difference between the Cost (current US$) in Minerals in 2001 and the Cost (current US$) in Energy in 2002?
Your response must be concise. -2.03e+08. What is the difference between the Cost (current US$) of Minerals in 2001 and the Cost (current US$) of Forest in 2002?
Make the answer very short. -3.79e+08. What is the difference between the Cost (current US$) of Energy in 2001 and the Cost (current US$) of Forest in 2002?
Keep it short and to the point. -9.51e+07. What is the average Cost (current US$) of CO2 damage per year?
Provide a short and direct response. 2.08e+09. What is the average Cost (current US$) in Minerals per year?
Your answer should be very brief. 1.26e+08. What is the average Cost (current US$) of Energy per year?
Give a very brief answer. 1.96e+08. What is the average Cost (current US$) of Forest per year?
Provide a short and direct response. 2.80e+08. In the year 1994, what is the difference between the Cost (current US$) of CO2 damage and Cost (current US$) of Minerals?
Your answer should be very brief. 1.75e+09. In the year 1994, what is the difference between the Cost (current US$) of CO2 damage and Cost (current US$) of Energy?
Your response must be concise. 1.80e+09. In the year 1994, what is the difference between the Cost (current US$) of CO2 damage and Cost (current US$) of Forest?
Ensure brevity in your answer.  1.78e+09. In the year 1994, what is the difference between the Cost (current US$) in Minerals and Cost (current US$) in Energy?
Provide a succinct answer. 4.49e+07. In the year 1994, what is the difference between the Cost (current US$) of Minerals and Cost (current US$) of Forest?
Provide a succinct answer. 2.89e+07. In the year 1994, what is the difference between the Cost (current US$) in Energy and Cost (current US$) in Forest?
Your answer should be compact. -1.60e+07. In the year 1995, what is the difference between the Cost (current US$) of CO2 damage and Cost (current US$) of Minerals?
Make the answer very short. 1.79e+09. In the year 1995, what is the difference between the Cost (current US$) of CO2 damage and Cost (current US$) of Energy?
Your answer should be very brief. 1.91e+09. In the year 1995, what is the difference between the Cost (current US$) of CO2 damage and Cost (current US$) of Forest?
Your answer should be compact. 1.82e+09. In the year 1995, what is the difference between the Cost (current US$) of Minerals and Cost (current US$) of Energy?
Your response must be concise. 1.25e+08. In the year 1995, what is the difference between the Cost (current US$) in Minerals and Cost (current US$) in Forest?
Offer a terse response. 3.65e+07. In the year 1995, what is the difference between the Cost (current US$) of Energy and Cost (current US$) of Forest?
Your response must be concise. -8.80e+07. In the year 1996, what is the difference between the Cost (current US$) of CO2 damage and Cost (current US$) of Minerals?
Ensure brevity in your answer.  2.00e+09. In the year 1996, what is the difference between the Cost (current US$) in CO2 damage and Cost (current US$) in Energy?
Ensure brevity in your answer.  1.99e+09. In the year 1996, what is the difference between the Cost (current US$) in CO2 damage and Cost (current US$) in Forest?
Offer a terse response. 1.94e+09. In the year 1996, what is the difference between the Cost (current US$) of Minerals and Cost (current US$) of Energy?
Give a very brief answer. -5.83e+06. In the year 1996, what is the difference between the Cost (current US$) in Minerals and Cost (current US$) in Forest?
Offer a terse response. -5.67e+07. In the year 1996, what is the difference between the Cost (current US$) in Energy and Cost (current US$) in Forest?
Your answer should be compact. -5.09e+07. In the year 1997, what is the difference between the Cost (current US$) of CO2 damage and Cost (current US$) of Minerals?
Keep it short and to the point. 2.02e+09. In the year 1997, what is the difference between the Cost (current US$) of CO2 damage and Cost (current US$) of Energy?
Keep it short and to the point. 2.04e+09. In the year 1997, what is the difference between the Cost (current US$) of CO2 damage and Cost (current US$) of Forest?
Your answer should be compact. 1.94e+09. In the year 1997, what is the difference between the Cost (current US$) in Minerals and Cost (current US$) in Energy?
Offer a terse response. 1.37e+07. In the year 1997, what is the difference between the Cost (current US$) of Minerals and Cost (current US$) of Forest?
Give a very brief answer. -7.87e+07. In the year 1997, what is the difference between the Cost (current US$) in Energy and Cost (current US$) in Forest?
Your answer should be compact. -9.24e+07. In the year 1998, what is the difference between the Cost (current US$) in CO2 damage and Cost (current US$) in Minerals?
Your answer should be compact. 2.02e+09. In the year 1998, what is the difference between the Cost (current US$) in CO2 damage and Cost (current US$) in Energy?
Your response must be concise. 1.96e+09. In the year 1998, what is the difference between the Cost (current US$) in CO2 damage and Cost (current US$) in Forest?
Give a very brief answer. 1.79e+09. In the year 1998, what is the difference between the Cost (current US$) in Minerals and Cost (current US$) in Energy?
Give a very brief answer. -5.80e+07. In the year 1998, what is the difference between the Cost (current US$) of Minerals and Cost (current US$) of Forest?
Give a very brief answer. -2.26e+08. In the year 1998, what is the difference between the Cost (current US$) of Energy and Cost (current US$) of Forest?
Offer a very short reply. -1.68e+08. In the year 1999, what is the difference between the Cost (current US$) of CO2 damage and Cost (current US$) of Minerals?
Your answer should be very brief. 2.02e+09. In the year 1999, what is the difference between the Cost (current US$) of CO2 damage and Cost (current US$) of Energy?
Ensure brevity in your answer.  1.97e+09. In the year 1999, what is the difference between the Cost (current US$) of CO2 damage and Cost (current US$) of Forest?
Your answer should be compact. 1.78e+09. In the year 1999, what is the difference between the Cost (current US$) in Minerals and Cost (current US$) in Energy?
Your answer should be very brief. -4.37e+07. In the year 1999, what is the difference between the Cost (current US$) of Minerals and Cost (current US$) of Forest?
Your answer should be compact. -2.39e+08. In the year 1999, what is the difference between the Cost (current US$) of Energy and Cost (current US$) of Forest?
Provide a succinct answer. -1.95e+08. In the year 2000, what is the difference between the Cost (current US$) of CO2 damage and Cost (current US$) of Minerals?
Ensure brevity in your answer.  1.92e+09. In the year 2000, what is the difference between the Cost (current US$) in CO2 damage and Cost (current US$) in Energy?
Ensure brevity in your answer.  1.70e+09. In the year 2000, what is the difference between the Cost (current US$) of CO2 damage and Cost (current US$) of Forest?
Ensure brevity in your answer.  1.68e+09. In the year 2000, what is the difference between the Cost (current US$) of Minerals and Cost (current US$) of Energy?
Keep it short and to the point. -2.28e+08. In the year 2000, what is the difference between the Cost (current US$) of Minerals and Cost (current US$) of Forest?
Your answer should be compact. -2.40e+08. In the year 2000, what is the difference between the Cost (current US$) of Energy and Cost (current US$) of Forest?
Offer a terse response. -1.20e+07. In the year 2001, what is the difference between the Cost (current US$) of CO2 damage and Cost (current US$) of Minerals?
Keep it short and to the point. 2.05e+09. In the year 2001, what is the difference between the Cost (current US$) of CO2 damage and Cost (current US$) of Energy?
Provide a short and direct response. 1.77e+09. In the year 2001, what is the difference between the Cost (current US$) of CO2 damage and Cost (current US$) of Forest?
Give a very brief answer. 1.81e+09. In the year 2001, what is the difference between the Cost (current US$) of Minerals and Cost (current US$) of Energy?
Provide a short and direct response. -2.84e+08. In the year 2001, what is the difference between the Cost (current US$) of Minerals and Cost (current US$) of Forest?
Your answer should be compact. -2.44e+08. In the year 2001, what is the difference between the Cost (current US$) in Energy and Cost (current US$) in Forest?
Offer a terse response. 4.05e+07. In the year 2002, what is the difference between the Cost (current US$) of CO2 damage and Cost (current US$) of Minerals?
Ensure brevity in your answer.  2.06e+09. In the year 2002, what is the difference between the Cost (current US$) of CO2 damage and Cost (current US$) of Energy?
Make the answer very short. 1.86e+09. In the year 2002, what is the difference between the Cost (current US$) of CO2 damage and Cost (current US$) of Forest?
Make the answer very short. 1.68e+09. In the year 2002, what is the difference between the Cost (current US$) in Minerals and Cost (current US$) in Energy?
Make the answer very short. -2.00e+08. In the year 2002, what is the difference between the Cost (current US$) of Minerals and Cost (current US$) of Forest?
Provide a short and direct response. -3.76e+08. In the year 2002, what is the difference between the Cost (current US$) in Energy and Cost (current US$) in Forest?
Make the answer very short. -1.76e+08. What is the ratio of the Cost (current US$) in CO2 damage in 1994 to that in 1995?
Offer a terse response. 0.94. What is the ratio of the Cost (current US$) of Minerals in 1994 to that in 1995?
Offer a terse response. 0.64. What is the ratio of the Cost (current US$) of Energy in 1994 to that in 1995?
Provide a succinct answer. 0.93. What is the ratio of the Cost (current US$) in Forest in 1994 to that in 1995?
Give a very brief answer. 0.62. What is the ratio of the Cost (current US$) of CO2 damage in 1994 to that in 1996?
Keep it short and to the point. 0.88. What is the ratio of the Cost (current US$) of Minerals in 1994 to that in 1996?
Your answer should be compact. 0.96. What is the ratio of the Cost (current US$) of Energy in 1994 to that in 1996?
Your answer should be compact. 0.67. What is the ratio of the Cost (current US$) in Forest in 1994 to that in 1996?
Your answer should be very brief. 0.59. What is the ratio of the Cost (current US$) in CO2 damage in 1994 to that in 1997?
Offer a very short reply. 0.87. What is the ratio of the Cost (current US$) of Minerals in 1994 to that in 1997?
Keep it short and to the point. 0.95. What is the ratio of the Cost (current US$) in Energy in 1994 to that in 1997?
Your answer should be compact. 0.75. What is the ratio of the Cost (current US$) in Forest in 1994 to that in 1997?
Your response must be concise. 0.53. What is the ratio of the Cost (current US$) of CO2 damage in 1994 to that in 1998?
Offer a very short reply. 0.92. What is the ratio of the Cost (current US$) of Minerals in 1994 to that in 1998?
Your answer should be very brief. 2.42. What is the ratio of the Cost (current US$) in Energy in 1994 to that in 1998?
Give a very brief answer. 0.93. What is the ratio of the Cost (current US$) in Forest in 1994 to that in 1998?
Make the answer very short. 0.45. What is the ratio of the Cost (current US$) of CO2 damage in 1994 to that in 1999?
Offer a terse response. 0.92. What is the ratio of the Cost (current US$) in Minerals in 1994 to that in 1999?
Give a very brief answer. 2.68. What is the ratio of the Cost (current US$) in Energy in 1994 to that in 1999?
Provide a succinct answer. 1.12. What is the ratio of the Cost (current US$) of Forest in 1994 to that in 1999?
Keep it short and to the point. 0.44. What is the ratio of the Cost (current US$) of CO2 damage in 1994 to that in 2000?
Ensure brevity in your answer.  0.94. What is the ratio of the Cost (current US$) of Minerals in 1994 to that in 2000?
Offer a terse response. 1.41. What is the ratio of the Cost (current US$) of Energy in 1994 to that in 2000?
Ensure brevity in your answer.  0.34. What is the ratio of the Cost (current US$) of Forest in 1994 to that in 2000?
Your response must be concise. 0.37. What is the ratio of the Cost (current US$) in CO2 damage in 1994 to that in 2001?
Offer a very short reply. 0.9. What is the ratio of the Cost (current US$) of Minerals in 1994 to that in 2001?
Give a very brief answer. 2.25. What is the ratio of the Cost (current US$) of Energy in 1994 to that in 2001?
Offer a very short reply. 0.32. What is the ratio of the Cost (current US$) of Forest in 1994 to that in 2001?
Keep it short and to the point. 0.42. What is the ratio of the Cost (current US$) of CO2 damage in 1994 to that in 2002?
Provide a short and direct response. 0.9. What is the ratio of the Cost (current US$) in Minerals in 1994 to that in 2002?
Your answer should be very brief. 2.14. What is the ratio of the Cost (current US$) of Energy in 1994 to that in 2002?
Make the answer very short. 0.42. What is the ratio of the Cost (current US$) in Forest in 1994 to that in 2002?
Make the answer very short. 0.29. What is the ratio of the Cost (current US$) in CO2 damage in 1995 to that in 1996?
Keep it short and to the point. 0.94. What is the ratio of the Cost (current US$) in Minerals in 1995 to that in 1996?
Offer a terse response. 1.49. What is the ratio of the Cost (current US$) in Energy in 1995 to that in 1996?
Your response must be concise. 0.72. What is the ratio of the Cost (current US$) in Forest in 1995 to that in 1996?
Keep it short and to the point. 0.95. What is the ratio of the Cost (current US$) in CO2 damage in 1995 to that in 1997?
Offer a terse response. 0.93. What is the ratio of the Cost (current US$) in Minerals in 1995 to that in 1997?
Your answer should be very brief. 1.48. What is the ratio of the Cost (current US$) in Energy in 1995 to that in 1997?
Ensure brevity in your answer.  0.8. What is the ratio of the Cost (current US$) in Forest in 1995 to that in 1997?
Provide a succinct answer. 0.86. What is the ratio of the Cost (current US$) in CO2 damage in 1995 to that in 1998?
Your answer should be compact. 0.98. What is the ratio of the Cost (current US$) of Minerals in 1995 to that in 1998?
Your answer should be very brief. 3.76. What is the ratio of the Cost (current US$) in Energy in 1995 to that in 1998?
Provide a succinct answer. 1. What is the ratio of the Cost (current US$) in Forest in 1995 to that in 1998?
Your answer should be compact. 0.73. What is the ratio of the Cost (current US$) in CO2 damage in 1995 to that in 1999?
Make the answer very short. 0.98. What is the ratio of the Cost (current US$) in Minerals in 1995 to that in 1999?
Offer a terse response. 4.16. What is the ratio of the Cost (current US$) in Energy in 1995 to that in 1999?
Offer a very short reply. 1.2. What is the ratio of the Cost (current US$) in Forest in 1995 to that in 1999?
Provide a succinct answer. 0.71. What is the ratio of the Cost (current US$) in Minerals in 1995 to that in 2000?
Provide a succinct answer. 2.19. What is the ratio of the Cost (current US$) of Energy in 1995 to that in 2000?
Offer a terse response. 0.36. What is the ratio of the Cost (current US$) of Forest in 1995 to that in 2000?
Offer a terse response. 0.6. What is the ratio of the Cost (current US$) in CO2 damage in 1995 to that in 2001?
Offer a terse response. 0.96. What is the ratio of the Cost (current US$) in Minerals in 1995 to that in 2001?
Provide a succinct answer. 3.49. What is the ratio of the Cost (current US$) of Energy in 1995 to that in 2001?
Your answer should be compact. 0.35. What is the ratio of the Cost (current US$) in Forest in 1995 to that in 2001?
Provide a short and direct response. 0.67. What is the ratio of the Cost (current US$) in CO2 damage in 1995 to that in 2002?
Provide a short and direct response. 0.95. What is the ratio of the Cost (current US$) in Minerals in 1995 to that in 2002?
Offer a very short reply. 3.32. What is the ratio of the Cost (current US$) of Energy in 1995 to that in 2002?
Your response must be concise. 0.45. What is the ratio of the Cost (current US$) in Forest in 1995 to that in 2002?
Make the answer very short. 0.47. What is the ratio of the Cost (current US$) of Minerals in 1996 to that in 1997?
Give a very brief answer. 1. What is the ratio of the Cost (current US$) in Energy in 1996 to that in 1997?
Your answer should be very brief. 1.12. What is the ratio of the Cost (current US$) in Forest in 1996 to that in 1997?
Give a very brief answer. 0.91. What is the ratio of the Cost (current US$) of CO2 damage in 1996 to that in 1998?
Your answer should be very brief. 1.04. What is the ratio of the Cost (current US$) in Minerals in 1996 to that in 1998?
Your answer should be compact. 2.53. What is the ratio of the Cost (current US$) of Energy in 1996 to that in 1998?
Offer a very short reply. 1.39. What is the ratio of the Cost (current US$) in Forest in 1996 to that in 1998?
Keep it short and to the point. 0.77. What is the ratio of the Cost (current US$) in CO2 damage in 1996 to that in 1999?
Provide a short and direct response. 1.04. What is the ratio of the Cost (current US$) of Minerals in 1996 to that in 1999?
Provide a succinct answer. 2.8. What is the ratio of the Cost (current US$) in Energy in 1996 to that in 1999?
Your answer should be compact. 1.67. What is the ratio of the Cost (current US$) of Forest in 1996 to that in 1999?
Offer a very short reply. 0.75. What is the ratio of the Cost (current US$) in Minerals in 1996 to that in 2000?
Give a very brief answer. 1.47. What is the ratio of the Cost (current US$) of Energy in 1996 to that in 2000?
Offer a terse response. 0.51. What is the ratio of the Cost (current US$) of Forest in 1996 to that in 2000?
Provide a succinct answer. 0.63. What is the ratio of the Cost (current US$) of Minerals in 1996 to that in 2001?
Offer a very short reply. 2.35. What is the ratio of the Cost (current US$) of Energy in 1996 to that in 2001?
Offer a very short reply. 0.49. What is the ratio of the Cost (current US$) in Forest in 1996 to that in 2001?
Keep it short and to the point. 0.71. What is the ratio of the Cost (current US$) of CO2 damage in 1996 to that in 2002?
Your response must be concise. 1.01. What is the ratio of the Cost (current US$) of Minerals in 1996 to that in 2002?
Ensure brevity in your answer.  2.23. What is the ratio of the Cost (current US$) of Energy in 1996 to that in 2002?
Your answer should be compact. 0.63. What is the ratio of the Cost (current US$) in Forest in 1996 to that in 2002?
Your response must be concise. 0.5. What is the ratio of the Cost (current US$) in CO2 damage in 1997 to that in 1998?
Provide a succinct answer. 1.05. What is the ratio of the Cost (current US$) in Minerals in 1997 to that in 1998?
Your answer should be very brief. 2.54. What is the ratio of the Cost (current US$) of Energy in 1997 to that in 1998?
Give a very brief answer. 1.24. What is the ratio of the Cost (current US$) of Forest in 1997 to that in 1998?
Your answer should be compact. 0.85. What is the ratio of the Cost (current US$) in CO2 damage in 1997 to that in 1999?
Your response must be concise. 1.05. What is the ratio of the Cost (current US$) in Minerals in 1997 to that in 1999?
Make the answer very short. 2.81. What is the ratio of the Cost (current US$) in Energy in 1997 to that in 1999?
Your answer should be compact. 1.49. What is the ratio of the Cost (current US$) of Forest in 1997 to that in 1999?
Your response must be concise. 0.83. What is the ratio of the Cost (current US$) of CO2 damage in 1997 to that in 2000?
Provide a succinct answer. 1.07. What is the ratio of the Cost (current US$) in Minerals in 1997 to that in 2000?
Provide a short and direct response. 1.48. What is the ratio of the Cost (current US$) of Energy in 1997 to that in 2000?
Offer a very short reply. 0.45. What is the ratio of the Cost (current US$) in Forest in 1997 to that in 2000?
Provide a succinct answer. 0.7. What is the ratio of the Cost (current US$) in CO2 damage in 1997 to that in 2001?
Ensure brevity in your answer.  1.03. What is the ratio of the Cost (current US$) in Minerals in 1997 to that in 2001?
Give a very brief answer. 2.36. What is the ratio of the Cost (current US$) in Energy in 1997 to that in 2001?
Your answer should be compact. 0.43. What is the ratio of the Cost (current US$) in Forest in 1997 to that in 2001?
Provide a succinct answer. 0.78. What is the ratio of the Cost (current US$) in CO2 damage in 1997 to that in 2002?
Your answer should be very brief. 1.03. What is the ratio of the Cost (current US$) in Minerals in 1997 to that in 2002?
Offer a very short reply. 2.24. What is the ratio of the Cost (current US$) in Energy in 1997 to that in 2002?
Your answer should be very brief. 0.56. What is the ratio of the Cost (current US$) in Forest in 1997 to that in 2002?
Provide a succinct answer. 0.55. What is the ratio of the Cost (current US$) in CO2 damage in 1998 to that in 1999?
Provide a short and direct response. 1. What is the ratio of the Cost (current US$) of Minerals in 1998 to that in 1999?
Keep it short and to the point. 1.11. What is the ratio of the Cost (current US$) of Energy in 1998 to that in 1999?
Provide a short and direct response. 1.2. What is the ratio of the Cost (current US$) in Forest in 1998 to that in 1999?
Keep it short and to the point. 0.98. What is the ratio of the Cost (current US$) in CO2 damage in 1998 to that in 2000?
Ensure brevity in your answer.  1.02. What is the ratio of the Cost (current US$) of Minerals in 1998 to that in 2000?
Your answer should be compact. 0.58. What is the ratio of the Cost (current US$) of Energy in 1998 to that in 2000?
Make the answer very short. 0.36. What is the ratio of the Cost (current US$) in Forest in 1998 to that in 2000?
Your response must be concise. 0.82. What is the ratio of the Cost (current US$) in Minerals in 1998 to that in 2001?
Give a very brief answer. 0.93. What is the ratio of the Cost (current US$) in Energy in 1998 to that in 2001?
Give a very brief answer. 0.35. What is the ratio of the Cost (current US$) of Forest in 1998 to that in 2001?
Your answer should be very brief. 0.93. What is the ratio of the Cost (current US$) of CO2 damage in 1998 to that in 2002?
Provide a short and direct response. 0.98. What is the ratio of the Cost (current US$) in Minerals in 1998 to that in 2002?
Your answer should be very brief. 0.88. What is the ratio of the Cost (current US$) in Energy in 1998 to that in 2002?
Your answer should be compact. 0.45. What is the ratio of the Cost (current US$) of Forest in 1998 to that in 2002?
Provide a short and direct response. 0.65. What is the ratio of the Cost (current US$) of CO2 damage in 1999 to that in 2000?
Ensure brevity in your answer.  1.02. What is the ratio of the Cost (current US$) of Minerals in 1999 to that in 2000?
Your response must be concise. 0.53. What is the ratio of the Cost (current US$) in Energy in 1999 to that in 2000?
Keep it short and to the point. 0.3. What is the ratio of the Cost (current US$) in Forest in 1999 to that in 2000?
Keep it short and to the point. 0.84. What is the ratio of the Cost (current US$) in CO2 damage in 1999 to that in 2001?
Offer a terse response. 0.98. What is the ratio of the Cost (current US$) in Minerals in 1999 to that in 2001?
Offer a terse response. 0.84. What is the ratio of the Cost (current US$) in Energy in 1999 to that in 2001?
Ensure brevity in your answer.  0.29. What is the ratio of the Cost (current US$) in Forest in 1999 to that in 2001?
Your answer should be compact. 0.95. What is the ratio of the Cost (current US$) of CO2 damage in 1999 to that in 2002?
Your answer should be very brief. 0.97. What is the ratio of the Cost (current US$) of Minerals in 1999 to that in 2002?
Your answer should be compact. 0.8. What is the ratio of the Cost (current US$) in Energy in 1999 to that in 2002?
Ensure brevity in your answer.  0.38. What is the ratio of the Cost (current US$) in Forest in 1999 to that in 2002?
Ensure brevity in your answer.  0.66. What is the ratio of the Cost (current US$) of Minerals in 2000 to that in 2001?
Keep it short and to the point. 1.6. What is the ratio of the Cost (current US$) in Energy in 2000 to that in 2001?
Keep it short and to the point. 0.96. What is the ratio of the Cost (current US$) of Forest in 2000 to that in 2001?
Provide a short and direct response. 1.12. What is the ratio of the Cost (current US$) in CO2 damage in 2000 to that in 2002?
Keep it short and to the point. 0.95. What is the ratio of the Cost (current US$) of Minerals in 2000 to that in 2002?
Offer a very short reply. 1.52. What is the ratio of the Cost (current US$) in Energy in 2000 to that in 2002?
Your response must be concise. 1.25. What is the ratio of the Cost (current US$) in Forest in 2000 to that in 2002?
Your response must be concise. 0.79. What is the ratio of the Cost (current US$) of Energy in 2001 to that in 2002?
Make the answer very short. 1.29. What is the ratio of the Cost (current US$) of Forest in 2001 to that in 2002?
Provide a succinct answer. 0.7. What is the difference between the highest and the second highest Cost (current US$) of CO2 damage?
Your answer should be very brief. 2.39e+07. What is the difference between the highest and the second highest Cost (current US$) of Minerals?
Offer a very short reply. 8.05e+07. What is the difference between the highest and the second highest Cost (current US$) of Energy?
Ensure brevity in your answer.  1.34e+07. What is the difference between the highest and the second highest Cost (current US$) in Forest?
Offer a very short reply. 9.65e+07. What is the difference between the highest and the lowest Cost (current US$) of CO2 damage?
Your answer should be compact. 2.79e+08. What is the difference between the highest and the lowest Cost (current US$) of Minerals?
Your answer should be very brief. 1.89e+08. What is the difference between the highest and the lowest Cost (current US$) in Energy?
Your answer should be very brief. 2.52e+08. What is the difference between the highest and the lowest Cost (current US$) of Forest?
Give a very brief answer. 3.19e+08. 